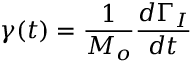Convert formula to latex. <formula><loc_0><loc_0><loc_500><loc_500>\gamma ( t ) = \frac { 1 } { M _ { o } } \frac { d \Gamma _ { I } } { d t }</formula> 